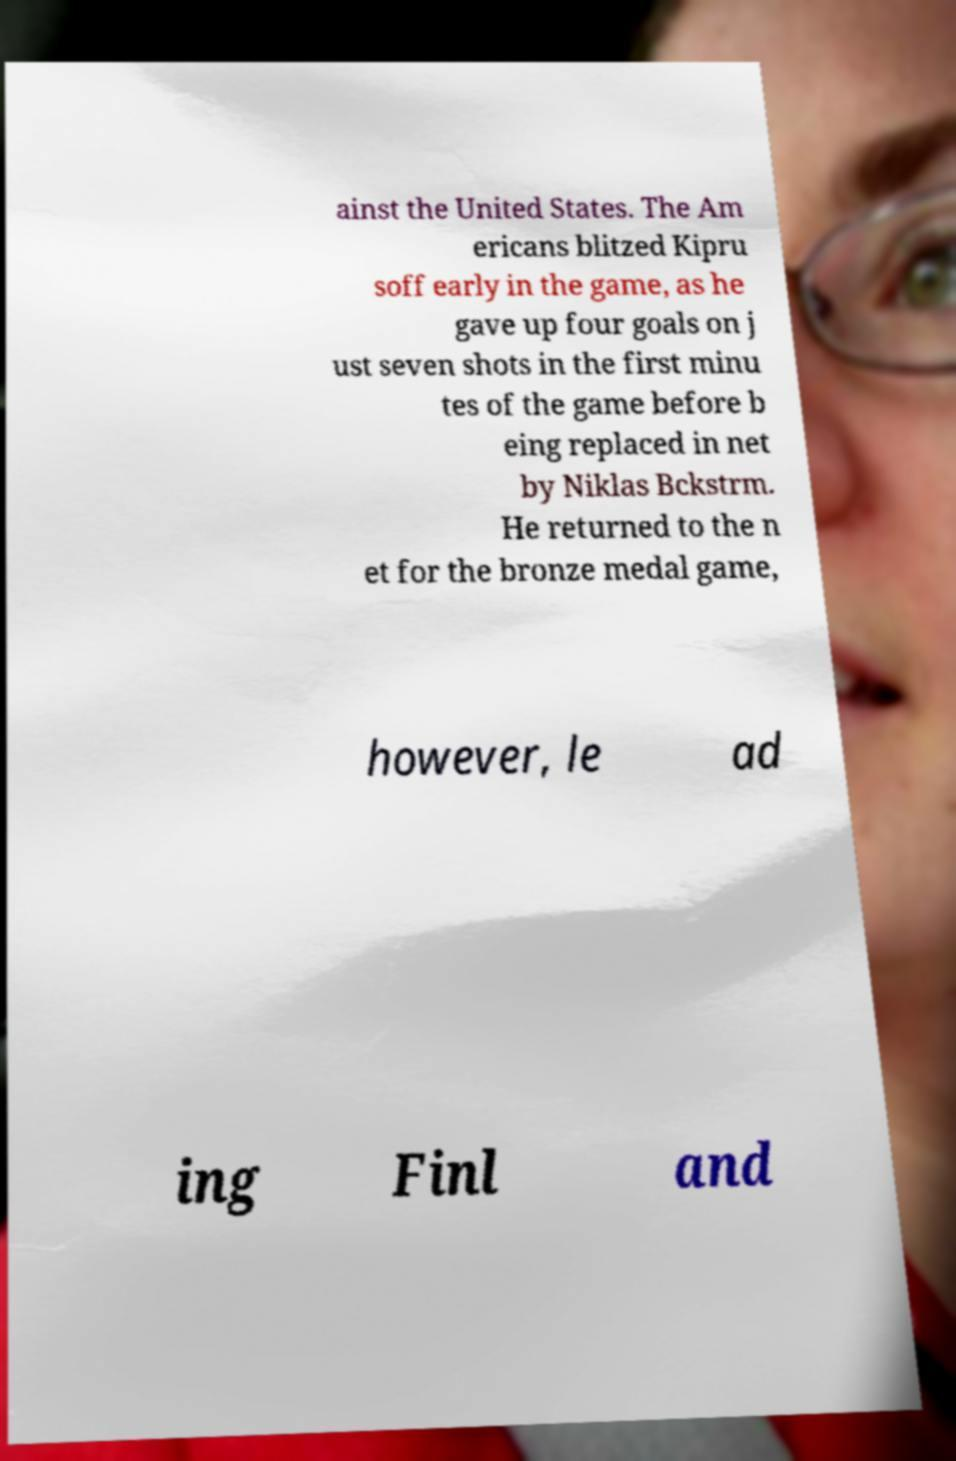Could you extract and type out the text from this image? ainst the United States. The Am ericans blitzed Kipru soff early in the game, as he gave up four goals on j ust seven shots in the first minu tes of the game before b eing replaced in net by Niklas Bckstrm. He returned to the n et for the bronze medal game, however, le ad ing Finl and 